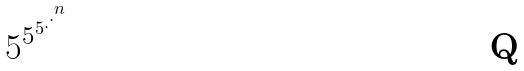<formula> <loc_0><loc_0><loc_500><loc_500>5 ^ { 5 ^ { 5 ^ { . ^ { . ^ { n } } } } }</formula> 